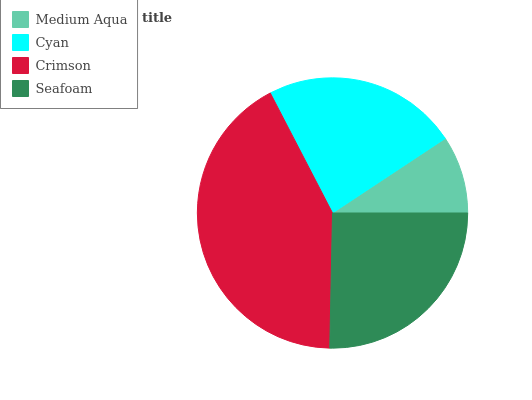Is Medium Aqua the minimum?
Answer yes or no. Yes. Is Crimson the maximum?
Answer yes or no. Yes. Is Cyan the minimum?
Answer yes or no. No. Is Cyan the maximum?
Answer yes or no. No. Is Cyan greater than Medium Aqua?
Answer yes or no. Yes. Is Medium Aqua less than Cyan?
Answer yes or no. Yes. Is Medium Aqua greater than Cyan?
Answer yes or no. No. Is Cyan less than Medium Aqua?
Answer yes or no. No. Is Seafoam the high median?
Answer yes or no. Yes. Is Cyan the low median?
Answer yes or no. Yes. Is Crimson the high median?
Answer yes or no. No. Is Crimson the low median?
Answer yes or no. No. 